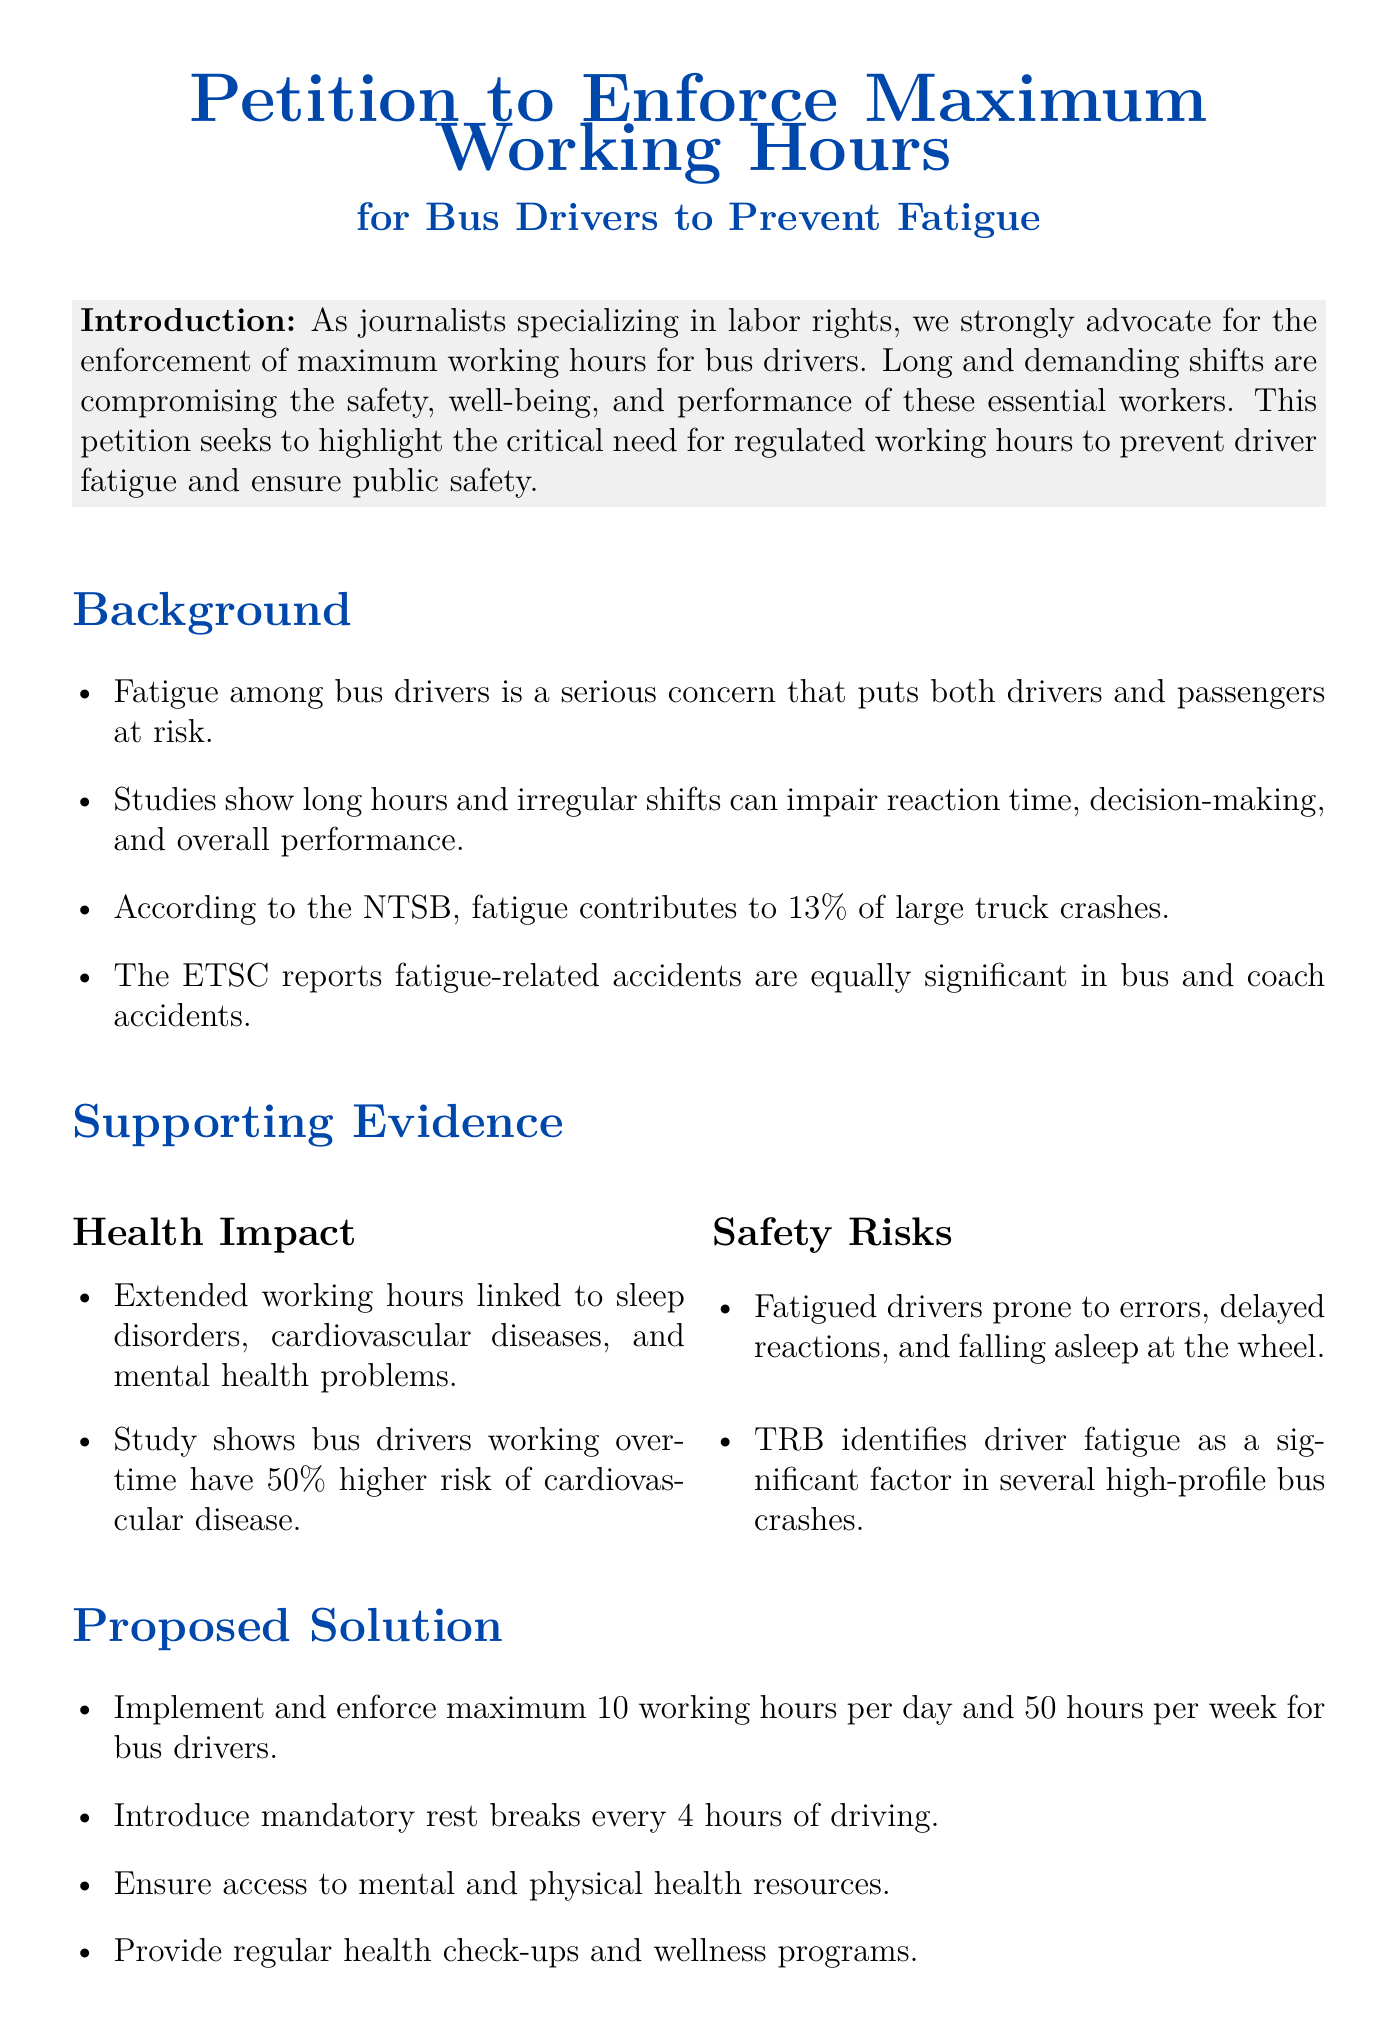What is the main purpose of the petition? The petition aims to enforce maximum working hours for bus drivers to prevent fatigue.
Answer: To prevent fatigue How many hours per day does the petition propose as a maximum for bus drivers? The petition suggests a maximum of 10 working hours per day for bus drivers.
Answer: 10 hours What percentage increase in cardiovascular disease risk is associated with bus drivers working overtime? The petition states that bus drivers working overtime have a 50% higher risk of cardiovascular disease.
Answer: 50% What organization reports that fatigue contributes to 13% of large truck crashes? The National Transportation Safety Board (NTSB) reports this statistic in the petition.
Answer: NTSB What is one proposed solution for ensuring driver well-being? One solution is to introduce mandatory rest breaks every 4 hours of driving.
Answer: Mandatory rest breaks What does the call to action urge local government bodies to adopt? The call to action urges the adoption and enforcement of measures to limit bus drivers’ working hours.
Answer: To limit working hours Which two health issues are linked to extended working hours in bus drivers? The petition links extended working hours to sleep disorders and cardiovascular diseases.
Answer: Sleep disorders, cardiovascular diseases What color is used for the title of the petition? The title of the petition is in blue color, referred to as "busblue."
Answer: Busblue 